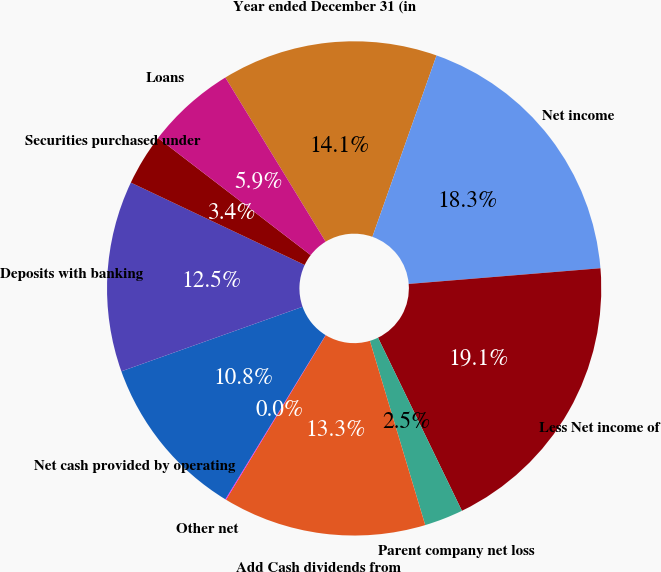Convert chart. <chart><loc_0><loc_0><loc_500><loc_500><pie_chart><fcel>Year ended December 31 (in<fcel>Net income<fcel>Less Net income of<fcel>Parent company net loss<fcel>Add Cash dividends from<fcel>Other net<fcel>Net cash provided by operating<fcel>Deposits with banking<fcel>Securities purchased under<fcel>Loans<nl><fcel>14.14%<fcel>18.29%<fcel>19.12%<fcel>2.54%<fcel>13.32%<fcel>0.05%<fcel>10.83%<fcel>12.49%<fcel>3.37%<fcel>5.86%<nl></chart> 